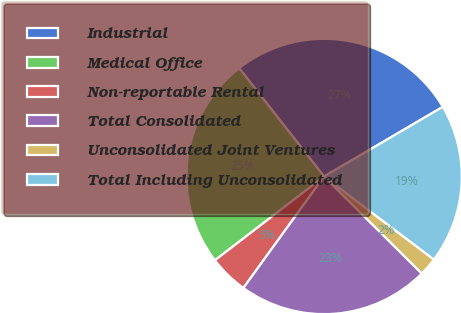Convert chart to OTSL. <chart><loc_0><loc_0><loc_500><loc_500><pie_chart><fcel>Industrial<fcel>Medical Office<fcel>Non-reportable Rental<fcel>Total Consolidated<fcel>Unconsolidated Joint Ventures<fcel>Total Including Unconsolidated<nl><fcel>27.14%<fcel>24.84%<fcel>4.61%<fcel>22.53%<fcel>2.14%<fcel>18.75%<nl></chart> 